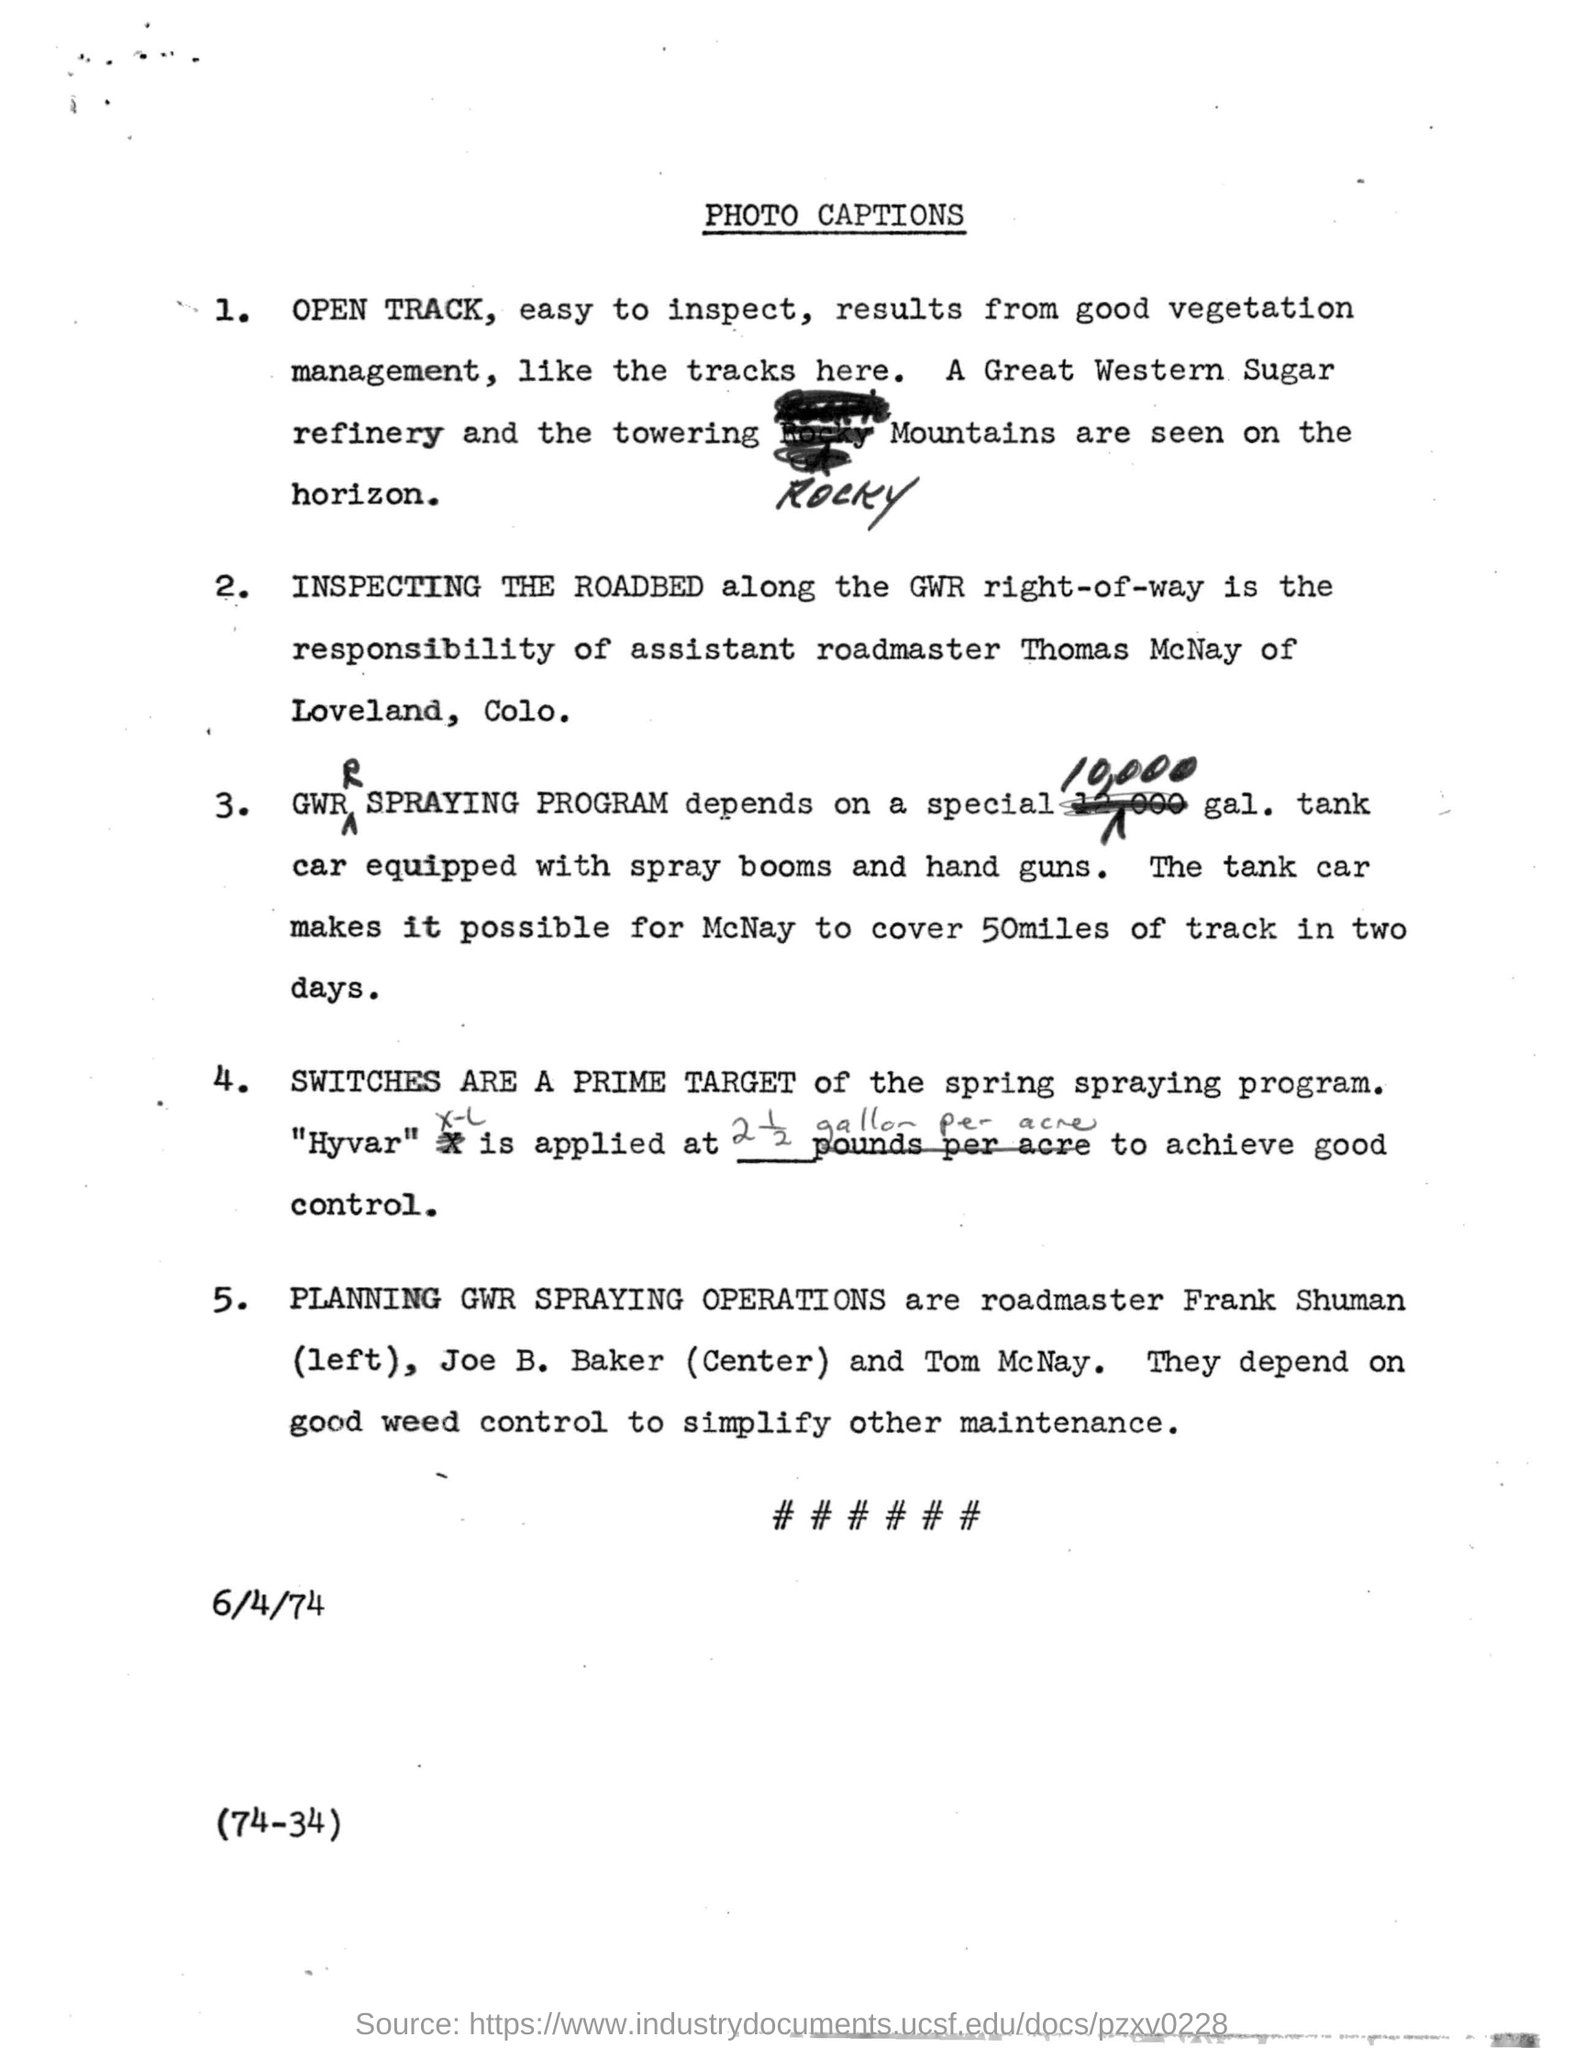Draw attention to some important aspects in this diagram. The prime target of the spring spraying program is to eradicate the pests known as SWITCHES. Thomas McNay is the Assistant Roadmaster of Loveland. The date mentioned in the document is 6/4/74. McNay can cover a distance of 50 miles in two days. The date given in the document is June 4th, 1974. 